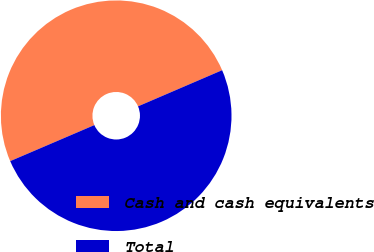Convert chart. <chart><loc_0><loc_0><loc_500><loc_500><pie_chart><fcel>Cash and cash equivalents<fcel>Total<nl><fcel>49.98%<fcel>50.02%<nl></chart> 